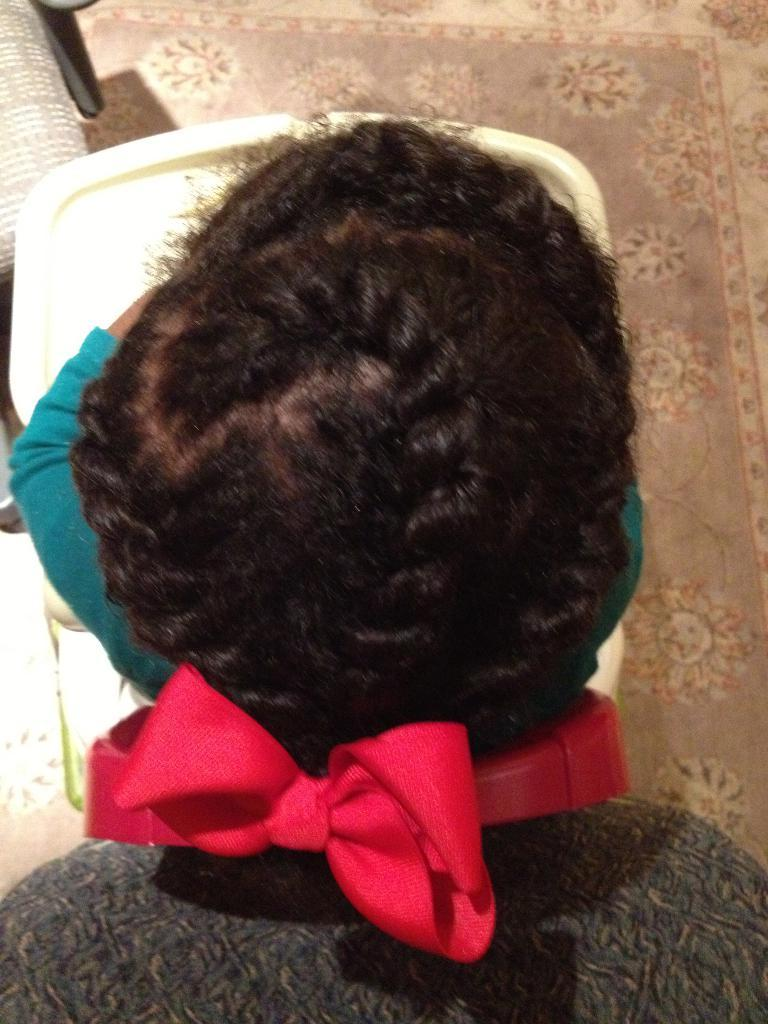What is the person in the image doing? The person is sitting on a chair in the image. What is in front of the person? There is a table in front of the person. What is in front of the table? There is a chair in front of the table. What is behind the person? There is a chair behind the person. What is at the bottom of the image? There is a mat at the bottom of the image. What type of sugar is the stranger using to sew the needle in the image? There is no sugar, stranger, or needle present in the image. 